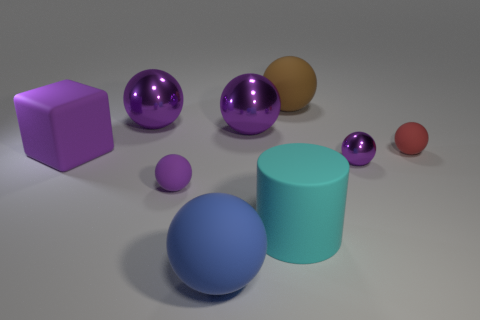What material is the brown thing that is the same shape as the blue matte object? While I'm unable to physically check the material, the brown object appears to be a 3D rendering, akin to the other objects in the scene, which means its material isn't real but digitally created to mimic a matte surface, potentially similar to plastic or wood in appearance. 